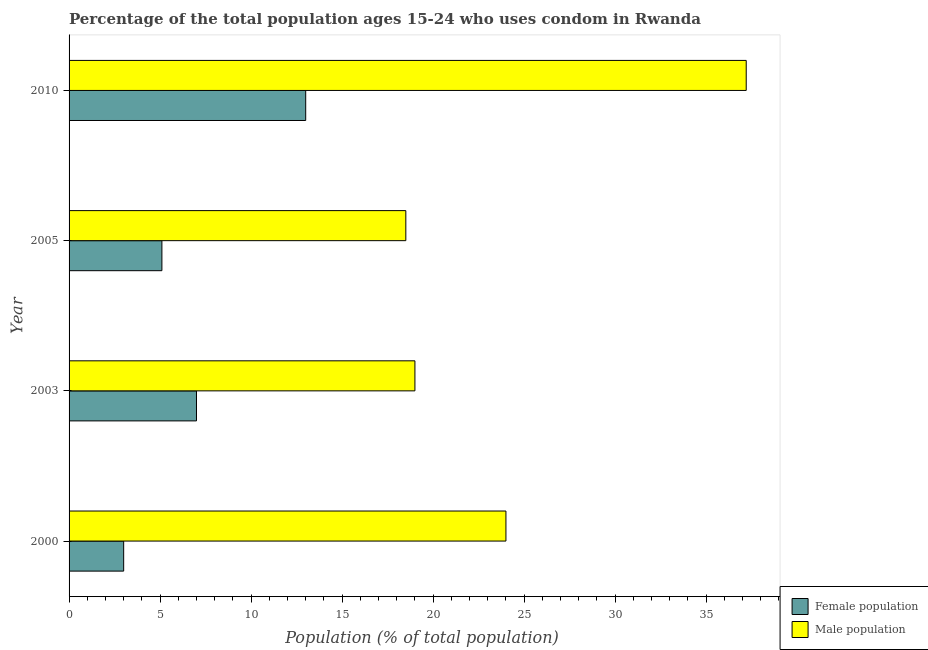Are the number of bars per tick equal to the number of legend labels?
Your answer should be compact. Yes. How many bars are there on the 4th tick from the top?
Keep it short and to the point. 2. Across all years, what is the maximum male population?
Give a very brief answer. 37.2. Across all years, what is the minimum female population?
Provide a short and direct response. 3. In which year was the female population maximum?
Offer a very short reply. 2010. In which year was the female population minimum?
Make the answer very short. 2000. What is the total female population in the graph?
Ensure brevity in your answer.  28.1. What is the difference between the male population in 2000 and that in 2005?
Offer a terse response. 5.5. What is the average female population per year?
Offer a terse response. 7.03. In the year 2005, what is the difference between the male population and female population?
Provide a succinct answer. 13.4. In how many years, is the female population greater than 26 %?
Your answer should be very brief. 0. What is the ratio of the female population in 2000 to that in 2005?
Your answer should be very brief. 0.59. What is the difference between the highest and the lowest male population?
Ensure brevity in your answer.  18.7. In how many years, is the male population greater than the average male population taken over all years?
Your answer should be very brief. 1. What does the 2nd bar from the top in 2003 represents?
Ensure brevity in your answer.  Female population. What does the 2nd bar from the bottom in 2000 represents?
Offer a terse response. Male population. Are all the bars in the graph horizontal?
Offer a terse response. Yes. How many years are there in the graph?
Your answer should be compact. 4. What is the difference between two consecutive major ticks on the X-axis?
Ensure brevity in your answer.  5. Where does the legend appear in the graph?
Make the answer very short. Bottom right. What is the title of the graph?
Make the answer very short. Percentage of the total population ages 15-24 who uses condom in Rwanda. What is the label or title of the X-axis?
Provide a short and direct response. Population (% of total population) . What is the label or title of the Y-axis?
Provide a succinct answer. Year. What is the Population (% of total population)  of Female population in 2000?
Your answer should be compact. 3. What is the Population (% of total population)  of Male population in 2005?
Your response must be concise. 18.5. What is the Population (% of total population)  in Female population in 2010?
Offer a terse response. 13. What is the Population (% of total population)  of Male population in 2010?
Keep it short and to the point. 37.2. Across all years, what is the maximum Population (% of total population)  of Female population?
Ensure brevity in your answer.  13. Across all years, what is the maximum Population (% of total population)  in Male population?
Give a very brief answer. 37.2. What is the total Population (% of total population)  of Female population in the graph?
Make the answer very short. 28.1. What is the total Population (% of total population)  in Male population in the graph?
Offer a terse response. 98.7. What is the difference between the Population (% of total population)  in Female population in 2000 and that in 2005?
Make the answer very short. -2.1. What is the difference between the Population (% of total population)  of Female population in 2000 and that in 2010?
Make the answer very short. -10. What is the difference between the Population (% of total population)  of Male population in 2000 and that in 2010?
Provide a short and direct response. -13.2. What is the difference between the Population (% of total population)  in Male population in 2003 and that in 2010?
Give a very brief answer. -18.2. What is the difference between the Population (% of total population)  in Female population in 2005 and that in 2010?
Offer a very short reply. -7.9. What is the difference between the Population (% of total population)  in Male population in 2005 and that in 2010?
Ensure brevity in your answer.  -18.7. What is the difference between the Population (% of total population)  in Female population in 2000 and the Population (% of total population)  in Male population in 2003?
Your response must be concise. -16. What is the difference between the Population (% of total population)  in Female population in 2000 and the Population (% of total population)  in Male population in 2005?
Offer a very short reply. -15.5. What is the difference between the Population (% of total population)  of Female population in 2000 and the Population (% of total population)  of Male population in 2010?
Your answer should be very brief. -34.2. What is the difference between the Population (% of total population)  in Female population in 2003 and the Population (% of total population)  in Male population in 2010?
Your answer should be very brief. -30.2. What is the difference between the Population (% of total population)  in Female population in 2005 and the Population (% of total population)  in Male population in 2010?
Your answer should be compact. -32.1. What is the average Population (% of total population)  of Female population per year?
Your answer should be very brief. 7.03. What is the average Population (% of total population)  of Male population per year?
Provide a short and direct response. 24.68. In the year 2003, what is the difference between the Population (% of total population)  of Female population and Population (% of total population)  of Male population?
Your answer should be compact. -12. In the year 2010, what is the difference between the Population (% of total population)  of Female population and Population (% of total population)  of Male population?
Your answer should be compact. -24.2. What is the ratio of the Population (% of total population)  in Female population in 2000 to that in 2003?
Give a very brief answer. 0.43. What is the ratio of the Population (% of total population)  in Male population in 2000 to that in 2003?
Your answer should be very brief. 1.26. What is the ratio of the Population (% of total population)  in Female population in 2000 to that in 2005?
Ensure brevity in your answer.  0.59. What is the ratio of the Population (% of total population)  in Male population in 2000 to that in 2005?
Your answer should be very brief. 1.3. What is the ratio of the Population (% of total population)  of Female population in 2000 to that in 2010?
Your answer should be compact. 0.23. What is the ratio of the Population (% of total population)  in Male population in 2000 to that in 2010?
Provide a succinct answer. 0.65. What is the ratio of the Population (% of total population)  in Female population in 2003 to that in 2005?
Keep it short and to the point. 1.37. What is the ratio of the Population (% of total population)  in Male population in 2003 to that in 2005?
Keep it short and to the point. 1.03. What is the ratio of the Population (% of total population)  in Female population in 2003 to that in 2010?
Your answer should be very brief. 0.54. What is the ratio of the Population (% of total population)  in Male population in 2003 to that in 2010?
Your answer should be compact. 0.51. What is the ratio of the Population (% of total population)  of Female population in 2005 to that in 2010?
Offer a terse response. 0.39. What is the ratio of the Population (% of total population)  of Male population in 2005 to that in 2010?
Keep it short and to the point. 0.5. What is the difference between the highest and the second highest Population (% of total population)  of Female population?
Your answer should be very brief. 6. What is the difference between the highest and the second highest Population (% of total population)  in Male population?
Your response must be concise. 13.2. What is the difference between the highest and the lowest Population (% of total population)  of Male population?
Offer a terse response. 18.7. 